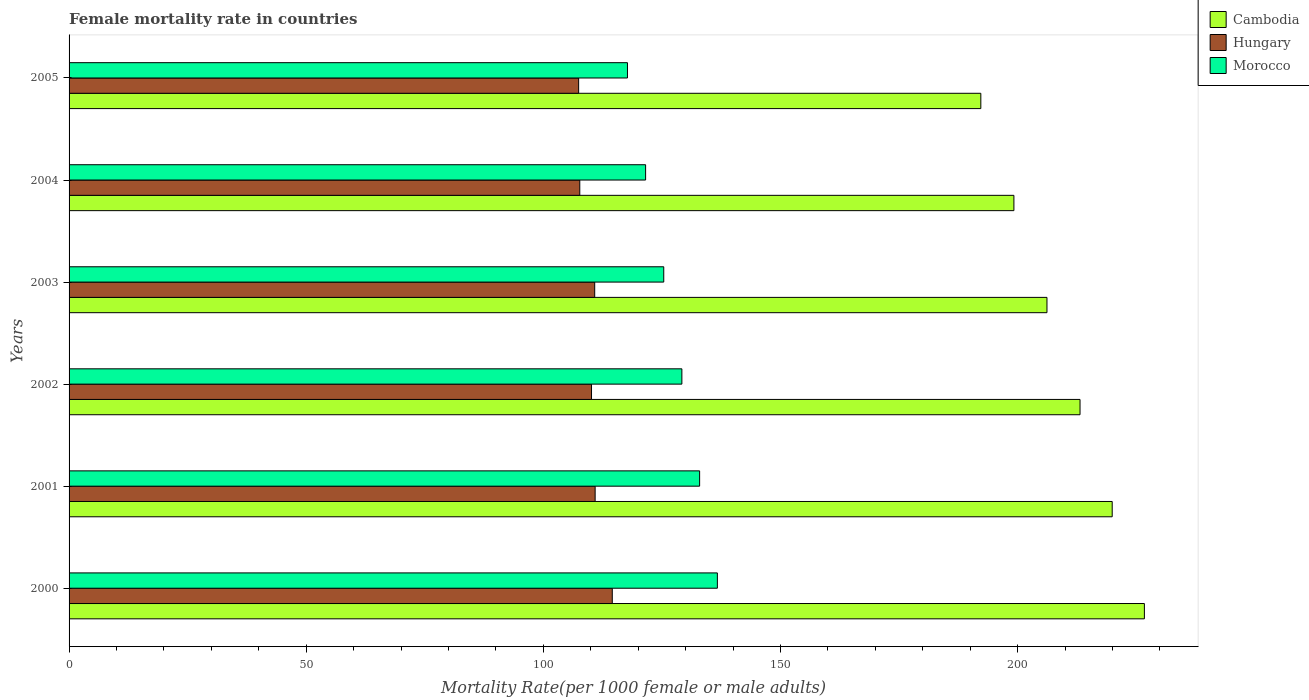How many different coloured bars are there?
Offer a terse response. 3. How many groups of bars are there?
Offer a terse response. 6. How many bars are there on the 3rd tick from the top?
Ensure brevity in your answer.  3. What is the label of the 3rd group of bars from the top?
Provide a succinct answer. 2003. In how many cases, is the number of bars for a given year not equal to the number of legend labels?
Offer a very short reply. 0. What is the female mortality rate in Hungary in 2005?
Your answer should be compact. 107.44. Across all years, what is the maximum female mortality rate in Morocco?
Your answer should be very brief. 136.69. Across all years, what is the minimum female mortality rate in Hungary?
Your answer should be compact. 107.44. In which year was the female mortality rate in Morocco minimum?
Keep it short and to the point. 2005. What is the total female mortality rate in Hungary in the graph?
Your response must be concise. 661.57. What is the difference between the female mortality rate in Hungary in 2002 and that in 2004?
Your response must be concise. 2.47. What is the difference between the female mortality rate in Hungary in 2003 and the female mortality rate in Cambodia in 2002?
Give a very brief answer. -102.33. What is the average female mortality rate in Morocco per year?
Offer a very short reply. 127.26. In the year 2003, what is the difference between the female mortality rate in Hungary and female mortality rate in Cambodia?
Keep it short and to the point. -95.36. In how many years, is the female mortality rate in Hungary greater than 210 ?
Offer a very short reply. 0. What is the ratio of the female mortality rate in Hungary in 2000 to that in 2001?
Your response must be concise. 1.03. Is the female mortality rate in Hungary in 2002 less than that in 2005?
Your response must be concise. No. Is the difference between the female mortality rate in Hungary in 2001 and 2004 greater than the difference between the female mortality rate in Cambodia in 2001 and 2004?
Ensure brevity in your answer.  No. What is the difference between the highest and the second highest female mortality rate in Hungary?
Keep it short and to the point. 3.61. What is the difference between the highest and the lowest female mortality rate in Morocco?
Ensure brevity in your answer.  18.95. In how many years, is the female mortality rate in Hungary greater than the average female mortality rate in Hungary taken over all years?
Your answer should be very brief. 3. Is the sum of the female mortality rate in Morocco in 2000 and 2001 greater than the maximum female mortality rate in Hungary across all years?
Ensure brevity in your answer.  Yes. What does the 3rd bar from the top in 2000 represents?
Offer a terse response. Cambodia. What does the 2nd bar from the bottom in 2000 represents?
Provide a succinct answer. Hungary. Is it the case that in every year, the sum of the female mortality rate in Cambodia and female mortality rate in Morocco is greater than the female mortality rate in Hungary?
Your response must be concise. Yes. Are all the bars in the graph horizontal?
Your answer should be very brief. Yes. What is the difference between two consecutive major ticks on the X-axis?
Keep it short and to the point. 50. Are the values on the major ticks of X-axis written in scientific E-notation?
Keep it short and to the point. No. Does the graph contain any zero values?
Provide a succinct answer. No. Where does the legend appear in the graph?
Offer a very short reply. Top right. How are the legend labels stacked?
Provide a short and direct response. Vertical. What is the title of the graph?
Keep it short and to the point. Female mortality rate in countries. Does "Algeria" appear as one of the legend labels in the graph?
Offer a very short reply. No. What is the label or title of the X-axis?
Offer a very short reply. Mortality Rate(per 1000 female or male adults). What is the label or title of the Y-axis?
Make the answer very short. Years. What is the Mortality Rate(per 1000 female or male adults) of Cambodia in 2000?
Your answer should be very brief. 226.73. What is the Mortality Rate(per 1000 female or male adults) in Hungary in 2000?
Offer a very short reply. 114.53. What is the Mortality Rate(per 1000 female or male adults) in Morocco in 2000?
Provide a succinct answer. 136.69. What is the Mortality Rate(per 1000 female or male adults) in Cambodia in 2001?
Your answer should be very brief. 219.95. What is the Mortality Rate(per 1000 female or male adults) in Hungary in 2001?
Give a very brief answer. 110.92. What is the Mortality Rate(per 1000 female or male adults) in Morocco in 2001?
Provide a short and direct response. 132.95. What is the Mortality Rate(per 1000 female or male adults) in Cambodia in 2002?
Give a very brief answer. 213.16. What is the Mortality Rate(per 1000 female or male adults) of Hungary in 2002?
Keep it short and to the point. 110.16. What is the Mortality Rate(per 1000 female or male adults) of Morocco in 2002?
Offer a very short reply. 129.21. What is the Mortality Rate(per 1000 female or male adults) of Cambodia in 2003?
Ensure brevity in your answer.  206.19. What is the Mortality Rate(per 1000 female or male adults) of Hungary in 2003?
Ensure brevity in your answer.  110.83. What is the Mortality Rate(per 1000 female or male adults) of Morocco in 2003?
Offer a terse response. 125.39. What is the Mortality Rate(per 1000 female or male adults) of Cambodia in 2004?
Keep it short and to the point. 199.22. What is the Mortality Rate(per 1000 female or male adults) in Hungary in 2004?
Your answer should be compact. 107.68. What is the Mortality Rate(per 1000 female or male adults) in Morocco in 2004?
Make the answer very short. 121.56. What is the Mortality Rate(per 1000 female or male adults) in Cambodia in 2005?
Your answer should be compact. 192.25. What is the Mortality Rate(per 1000 female or male adults) of Hungary in 2005?
Keep it short and to the point. 107.44. What is the Mortality Rate(per 1000 female or male adults) of Morocco in 2005?
Give a very brief answer. 117.74. Across all years, what is the maximum Mortality Rate(per 1000 female or male adults) in Cambodia?
Your response must be concise. 226.73. Across all years, what is the maximum Mortality Rate(per 1000 female or male adults) in Hungary?
Ensure brevity in your answer.  114.53. Across all years, what is the maximum Mortality Rate(per 1000 female or male adults) in Morocco?
Your answer should be very brief. 136.69. Across all years, what is the minimum Mortality Rate(per 1000 female or male adults) in Cambodia?
Your response must be concise. 192.25. Across all years, what is the minimum Mortality Rate(per 1000 female or male adults) in Hungary?
Provide a succinct answer. 107.44. Across all years, what is the minimum Mortality Rate(per 1000 female or male adults) in Morocco?
Offer a terse response. 117.74. What is the total Mortality Rate(per 1000 female or male adults) in Cambodia in the graph?
Ensure brevity in your answer.  1257.49. What is the total Mortality Rate(per 1000 female or male adults) of Hungary in the graph?
Give a very brief answer. 661.57. What is the total Mortality Rate(per 1000 female or male adults) of Morocco in the graph?
Keep it short and to the point. 763.55. What is the difference between the Mortality Rate(per 1000 female or male adults) in Cambodia in 2000 and that in 2001?
Your answer should be compact. 6.78. What is the difference between the Mortality Rate(per 1000 female or male adults) in Hungary in 2000 and that in 2001?
Your answer should be very brief. 3.61. What is the difference between the Mortality Rate(per 1000 female or male adults) of Morocco in 2000 and that in 2001?
Offer a terse response. 3.74. What is the difference between the Mortality Rate(per 1000 female or male adults) in Cambodia in 2000 and that in 2002?
Ensure brevity in your answer.  13.57. What is the difference between the Mortality Rate(per 1000 female or male adults) in Hungary in 2000 and that in 2002?
Keep it short and to the point. 4.38. What is the difference between the Mortality Rate(per 1000 female or male adults) in Morocco in 2000 and that in 2002?
Keep it short and to the point. 7.48. What is the difference between the Mortality Rate(per 1000 female or male adults) in Cambodia in 2000 and that in 2003?
Provide a short and direct response. 20.54. What is the difference between the Mortality Rate(per 1000 female or male adults) of Hungary in 2000 and that in 2003?
Provide a succinct answer. 3.71. What is the difference between the Mortality Rate(per 1000 female or male adults) in Morocco in 2000 and that in 2003?
Your answer should be compact. 11.31. What is the difference between the Mortality Rate(per 1000 female or male adults) in Cambodia in 2000 and that in 2004?
Keep it short and to the point. 27.51. What is the difference between the Mortality Rate(per 1000 female or male adults) of Hungary in 2000 and that in 2004?
Give a very brief answer. 6.85. What is the difference between the Mortality Rate(per 1000 female or male adults) in Morocco in 2000 and that in 2004?
Your answer should be compact. 15.13. What is the difference between the Mortality Rate(per 1000 female or male adults) of Cambodia in 2000 and that in 2005?
Provide a succinct answer. 34.48. What is the difference between the Mortality Rate(per 1000 female or male adults) in Hungary in 2000 and that in 2005?
Ensure brevity in your answer.  7.09. What is the difference between the Mortality Rate(per 1000 female or male adults) of Morocco in 2000 and that in 2005?
Provide a succinct answer. 18.95. What is the difference between the Mortality Rate(per 1000 female or male adults) of Cambodia in 2001 and that in 2002?
Offer a very short reply. 6.78. What is the difference between the Mortality Rate(per 1000 female or male adults) of Hungary in 2001 and that in 2002?
Your response must be concise. 0.77. What is the difference between the Mortality Rate(per 1000 female or male adults) of Morocco in 2001 and that in 2002?
Your response must be concise. 3.74. What is the difference between the Mortality Rate(per 1000 female or male adults) in Cambodia in 2001 and that in 2003?
Offer a very short reply. 13.76. What is the difference between the Mortality Rate(per 1000 female or male adults) in Hungary in 2001 and that in 2003?
Offer a very short reply. 0.09. What is the difference between the Mortality Rate(per 1000 female or male adults) of Morocco in 2001 and that in 2003?
Your answer should be very brief. 7.57. What is the difference between the Mortality Rate(per 1000 female or male adults) in Cambodia in 2001 and that in 2004?
Make the answer very short. 20.73. What is the difference between the Mortality Rate(per 1000 female or male adults) of Hungary in 2001 and that in 2004?
Keep it short and to the point. 3.24. What is the difference between the Mortality Rate(per 1000 female or male adults) in Morocco in 2001 and that in 2004?
Your answer should be compact. 11.39. What is the difference between the Mortality Rate(per 1000 female or male adults) of Cambodia in 2001 and that in 2005?
Give a very brief answer. 27.7. What is the difference between the Mortality Rate(per 1000 female or male adults) of Hungary in 2001 and that in 2005?
Keep it short and to the point. 3.48. What is the difference between the Mortality Rate(per 1000 female or male adults) in Morocco in 2001 and that in 2005?
Provide a succinct answer. 15.21. What is the difference between the Mortality Rate(per 1000 female or male adults) in Cambodia in 2002 and that in 2003?
Give a very brief answer. 6.97. What is the difference between the Mortality Rate(per 1000 female or male adults) in Hungary in 2002 and that in 2003?
Make the answer very short. -0.67. What is the difference between the Mortality Rate(per 1000 female or male adults) in Morocco in 2002 and that in 2003?
Your response must be concise. 3.82. What is the difference between the Mortality Rate(per 1000 female or male adults) of Cambodia in 2002 and that in 2004?
Your answer should be very brief. 13.94. What is the difference between the Mortality Rate(per 1000 female or male adults) in Hungary in 2002 and that in 2004?
Your answer should be very brief. 2.47. What is the difference between the Mortality Rate(per 1000 female or male adults) in Morocco in 2002 and that in 2004?
Provide a short and direct response. 7.65. What is the difference between the Mortality Rate(per 1000 female or male adults) in Cambodia in 2002 and that in 2005?
Offer a very short reply. 20.92. What is the difference between the Mortality Rate(per 1000 female or male adults) of Hungary in 2002 and that in 2005?
Give a very brief answer. 2.71. What is the difference between the Mortality Rate(per 1000 female or male adults) in Morocco in 2002 and that in 2005?
Offer a very short reply. 11.47. What is the difference between the Mortality Rate(per 1000 female or male adults) of Cambodia in 2003 and that in 2004?
Keep it short and to the point. 6.97. What is the difference between the Mortality Rate(per 1000 female or male adults) of Hungary in 2003 and that in 2004?
Provide a succinct answer. 3.15. What is the difference between the Mortality Rate(per 1000 female or male adults) of Morocco in 2003 and that in 2004?
Offer a very short reply. 3.82. What is the difference between the Mortality Rate(per 1000 female or male adults) of Cambodia in 2003 and that in 2005?
Make the answer very short. 13.95. What is the difference between the Mortality Rate(per 1000 female or male adults) of Hungary in 2003 and that in 2005?
Give a very brief answer. 3.39. What is the difference between the Mortality Rate(per 1000 female or male adults) in Morocco in 2003 and that in 2005?
Your response must be concise. 7.65. What is the difference between the Mortality Rate(per 1000 female or male adults) of Cambodia in 2004 and that in 2005?
Provide a short and direct response. 6.97. What is the difference between the Mortality Rate(per 1000 female or male adults) in Hungary in 2004 and that in 2005?
Make the answer very short. 0.24. What is the difference between the Mortality Rate(per 1000 female or male adults) of Morocco in 2004 and that in 2005?
Offer a very short reply. 3.82. What is the difference between the Mortality Rate(per 1000 female or male adults) in Cambodia in 2000 and the Mortality Rate(per 1000 female or male adults) in Hungary in 2001?
Offer a terse response. 115.81. What is the difference between the Mortality Rate(per 1000 female or male adults) in Cambodia in 2000 and the Mortality Rate(per 1000 female or male adults) in Morocco in 2001?
Offer a terse response. 93.78. What is the difference between the Mortality Rate(per 1000 female or male adults) of Hungary in 2000 and the Mortality Rate(per 1000 female or male adults) of Morocco in 2001?
Your response must be concise. -18.42. What is the difference between the Mortality Rate(per 1000 female or male adults) in Cambodia in 2000 and the Mortality Rate(per 1000 female or male adults) in Hungary in 2002?
Your answer should be very brief. 116.57. What is the difference between the Mortality Rate(per 1000 female or male adults) in Cambodia in 2000 and the Mortality Rate(per 1000 female or male adults) in Morocco in 2002?
Make the answer very short. 97.52. What is the difference between the Mortality Rate(per 1000 female or male adults) in Hungary in 2000 and the Mortality Rate(per 1000 female or male adults) in Morocco in 2002?
Ensure brevity in your answer.  -14.68. What is the difference between the Mortality Rate(per 1000 female or male adults) in Cambodia in 2000 and the Mortality Rate(per 1000 female or male adults) in Hungary in 2003?
Ensure brevity in your answer.  115.9. What is the difference between the Mortality Rate(per 1000 female or male adults) in Cambodia in 2000 and the Mortality Rate(per 1000 female or male adults) in Morocco in 2003?
Your answer should be very brief. 101.34. What is the difference between the Mortality Rate(per 1000 female or male adults) of Hungary in 2000 and the Mortality Rate(per 1000 female or male adults) of Morocco in 2003?
Keep it short and to the point. -10.85. What is the difference between the Mortality Rate(per 1000 female or male adults) of Cambodia in 2000 and the Mortality Rate(per 1000 female or male adults) of Hungary in 2004?
Provide a succinct answer. 119.05. What is the difference between the Mortality Rate(per 1000 female or male adults) of Cambodia in 2000 and the Mortality Rate(per 1000 female or male adults) of Morocco in 2004?
Your response must be concise. 105.17. What is the difference between the Mortality Rate(per 1000 female or male adults) of Hungary in 2000 and the Mortality Rate(per 1000 female or male adults) of Morocco in 2004?
Give a very brief answer. -7.03. What is the difference between the Mortality Rate(per 1000 female or male adults) in Cambodia in 2000 and the Mortality Rate(per 1000 female or male adults) in Hungary in 2005?
Your response must be concise. 119.29. What is the difference between the Mortality Rate(per 1000 female or male adults) of Cambodia in 2000 and the Mortality Rate(per 1000 female or male adults) of Morocco in 2005?
Provide a succinct answer. 108.99. What is the difference between the Mortality Rate(per 1000 female or male adults) in Hungary in 2000 and the Mortality Rate(per 1000 female or male adults) in Morocco in 2005?
Keep it short and to the point. -3.21. What is the difference between the Mortality Rate(per 1000 female or male adults) of Cambodia in 2001 and the Mortality Rate(per 1000 female or male adults) of Hungary in 2002?
Give a very brief answer. 109.79. What is the difference between the Mortality Rate(per 1000 female or male adults) of Cambodia in 2001 and the Mortality Rate(per 1000 female or male adults) of Morocco in 2002?
Ensure brevity in your answer.  90.73. What is the difference between the Mortality Rate(per 1000 female or male adults) in Hungary in 2001 and the Mortality Rate(per 1000 female or male adults) in Morocco in 2002?
Ensure brevity in your answer.  -18.29. What is the difference between the Mortality Rate(per 1000 female or male adults) of Cambodia in 2001 and the Mortality Rate(per 1000 female or male adults) of Hungary in 2003?
Ensure brevity in your answer.  109.12. What is the difference between the Mortality Rate(per 1000 female or male adults) of Cambodia in 2001 and the Mortality Rate(per 1000 female or male adults) of Morocco in 2003?
Offer a terse response. 94.56. What is the difference between the Mortality Rate(per 1000 female or male adults) in Hungary in 2001 and the Mortality Rate(per 1000 female or male adults) in Morocco in 2003?
Make the answer very short. -14.46. What is the difference between the Mortality Rate(per 1000 female or male adults) in Cambodia in 2001 and the Mortality Rate(per 1000 female or male adults) in Hungary in 2004?
Offer a very short reply. 112.26. What is the difference between the Mortality Rate(per 1000 female or male adults) in Cambodia in 2001 and the Mortality Rate(per 1000 female or male adults) in Morocco in 2004?
Ensure brevity in your answer.  98.38. What is the difference between the Mortality Rate(per 1000 female or male adults) of Hungary in 2001 and the Mortality Rate(per 1000 female or male adults) of Morocco in 2004?
Provide a succinct answer. -10.64. What is the difference between the Mortality Rate(per 1000 female or male adults) of Cambodia in 2001 and the Mortality Rate(per 1000 female or male adults) of Hungary in 2005?
Make the answer very short. 112.5. What is the difference between the Mortality Rate(per 1000 female or male adults) of Cambodia in 2001 and the Mortality Rate(per 1000 female or male adults) of Morocco in 2005?
Keep it short and to the point. 102.21. What is the difference between the Mortality Rate(per 1000 female or male adults) in Hungary in 2001 and the Mortality Rate(per 1000 female or male adults) in Morocco in 2005?
Your answer should be compact. -6.82. What is the difference between the Mortality Rate(per 1000 female or male adults) in Cambodia in 2002 and the Mortality Rate(per 1000 female or male adults) in Hungary in 2003?
Make the answer very short. 102.33. What is the difference between the Mortality Rate(per 1000 female or male adults) of Cambodia in 2002 and the Mortality Rate(per 1000 female or male adults) of Morocco in 2003?
Offer a very short reply. 87.78. What is the difference between the Mortality Rate(per 1000 female or male adults) in Hungary in 2002 and the Mortality Rate(per 1000 female or male adults) in Morocco in 2003?
Give a very brief answer. -15.23. What is the difference between the Mortality Rate(per 1000 female or male adults) of Cambodia in 2002 and the Mortality Rate(per 1000 female or male adults) of Hungary in 2004?
Give a very brief answer. 105.48. What is the difference between the Mortality Rate(per 1000 female or male adults) in Cambodia in 2002 and the Mortality Rate(per 1000 female or male adults) in Morocco in 2004?
Your answer should be compact. 91.6. What is the difference between the Mortality Rate(per 1000 female or male adults) in Hungary in 2002 and the Mortality Rate(per 1000 female or male adults) in Morocco in 2004?
Provide a succinct answer. -11.41. What is the difference between the Mortality Rate(per 1000 female or male adults) of Cambodia in 2002 and the Mortality Rate(per 1000 female or male adults) of Hungary in 2005?
Provide a succinct answer. 105.72. What is the difference between the Mortality Rate(per 1000 female or male adults) of Cambodia in 2002 and the Mortality Rate(per 1000 female or male adults) of Morocco in 2005?
Keep it short and to the point. 95.42. What is the difference between the Mortality Rate(per 1000 female or male adults) of Hungary in 2002 and the Mortality Rate(per 1000 female or male adults) of Morocco in 2005?
Make the answer very short. -7.58. What is the difference between the Mortality Rate(per 1000 female or male adults) in Cambodia in 2003 and the Mortality Rate(per 1000 female or male adults) in Hungary in 2004?
Provide a short and direct response. 98.51. What is the difference between the Mortality Rate(per 1000 female or male adults) of Cambodia in 2003 and the Mortality Rate(per 1000 female or male adults) of Morocco in 2004?
Make the answer very short. 84.63. What is the difference between the Mortality Rate(per 1000 female or male adults) of Hungary in 2003 and the Mortality Rate(per 1000 female or male adults) of Morocco in 2004?
Offer a very short reply. -10.73. What is the difference between the Mortality Rate(per 1000 female or male adults) of Cambodia in 2003 and the Mortality Rate(per 1000 female or male adults) of Hungary in 2005?
Make the answer very short. 98.75. What is the difference between the Mortality Rate(per 1000 female or male adults) in Cambodia in 2003 and the Mortality Rate(per 1000 female or male adults) in Morocco in 2005?
Your answer should be very brief. 88.45. What is the difference between the Mortality Rate(per 1000 female or male adults) of Hungary in 2003 and the Mortality Rate(per 1000 female or male adults) of Morocco in 2005?
Your answer should be compact. -6.91. What is the difference between the Mortality Rate(per 1000 female or male adults) in Cambodia in 2004 and the Mortality Rate(per 1000 female or male adults) in Hungary in 2005?
Your answer should be very brief. 91.77. What is the difference between the Mortality Rate(per 1000 female or male adults) of Cambodia in 2004 and the Mortality Rate(per 1000 female or male adults) of Morocco in 2005?
Offer a very short reply. 81.48. What is the difference between the Mortality Rate(per 1000 female or male adults) in Hungary in 2004 and the Mortality Rate(per 1000 female or male adults) in Morocco in 2005?
Provide a short and direct response. -10.06. What is the average Mortality Rate(per 1000 female or male adults) in Cambodia per year?
Provide a succinct answer. 209.58. What is the average Mortality Rate(per 1000 female or male adults) of Hungary per year?
Make the answer very short. 110.26. What is the average Mortality Rate(per 1000 female or male adults) in Morocco per year?
Ensure brevity in your answer.  127.26. In the year 2000, what is the difference between the Mortality Rate(per 1000 female or male adults) of Cambodia and Mortality Rate(per 1000 female or male adults) of Hungary?
Your answer should be compact. 112.19. In the year 2000, what is the difference between the Mortality Rate(per 1000 female or male adults) of Cambodia and Mortality Rate(per 1000 female or male adults) of Morocco?
Provide a short and direct response. 90.04. In the year 2000, what is the difference between the Mortality Rate(per 1000 female or male adults) in Hungary and Mortality Rate(per 1000 female or male adults) in Morocco?
Provide a short and direct response. -22.16. In the year 2001, what is the difference between the Mortality Rate(per 1000 female or male adults) of Cambodia and Mortality Rate(per 1000 female or male adults) of Hungary?
Ensure brevity in your answer.  109.02. In the year 2001, what is the difference between the Mortality Rate(per 1000 female or male adults) in Cambodia and Mortality Rate(per 1000 female or male adults) in Morocco?
Your answer should be very brief. 86.99. In the year 2001, what is the difference between the Mortality Rate(per 1000 female or male adults) in Hungary and Mortality Rate(per 1000 female or male adults) in Morocco?
Your answer should be compact. -22.03. In the year 2002, what is the difference between the Mortality Rate(per 1000 female or male adults) in Cambodia and Mortality Rate(per 1000 female or male adults) in Hungary?
Offer a terse response. 103. In the year 2002, what is the difference between the Mortality Rate(per 1000 female or male adults) of Cambodia and Mortality Rate(per 1000 female or male adults) of Morocco?
Offer a terse response. 83.95. In the year 2002, what is the difference between the Mortality Rate(per 1000 female or male adults) of Hungary and Mortality Rate(per 1000 female or male adults) of Morocco?
Offer a terse response. -19.05. In the year 2003, what is the difference between the Mortality Rate(per 1000 female or male adults) of Cambodia and Mortality Rate(per 1000 female or male adults) of Hungary?
Provide a succinct answer. 95.36. In the year 2003, what is the difference between the Mortality Rate(per 1000 female or male adults) of Cambodia and Mortality Rate(per 1000 female or male adults) of Morocco?
Offer a very short reply. 80.8. In the year 2003, what is the difference between the Mortality Rate(per 1000 female or male adults) of Hungary and Mortality Rate(per 1000 female or male adults) of Morocco?
Give a very brief answer. -14.56. In the year 2004, what is the difference between the Mortality Rate(per 1000 female or male adults) of Cambodia and Mortality Rate(per 1000 female or male adults) of Hungary?
Your answer should be very brief. 91.53. In the year 2004, what is the difference between the Mortality Rate(per 1000 female or male adults) in Cambodia and Mortality Rate(per 1000 female or male adults) in Morocco?
Provide a succinct answer. 77.65. In the year 2004, what is the difference between the Mortality Rate(per 1000 female or male adults) of Hungary and Mortality Rate(per 1000 female or male adults) of Morocco?
Give a very brief answer. -13.88. In the year 2005, what is the difference between the Mortality Rate(per 1000 female or male adults) in Cambodia and Mortality Rate(per 1000 female or male adults) in Hungary?
Provide a short and direct response. 84.8. In the year 2005, what is the difference between the Mortality Rate(per 1000 female or male adults) in Cambodia and Mortality Rate(per 1000 female or male adults) in Morocco?
Provide a succinct answer. 74.5. In the year 2005, what is the difference between the Mortality Rate(per 1000 female or male adults) in Hungary and Mortality Rate(per 1000 female or male adults) in Morocco?
Ensure brevity in your answer.  -10.3. What is the ratio of the Mortality Rate(per 1000 female or male adults) of Cambodia in 2000 to that in 2001?
Make the answer very short. 1.03. What is the ratio of the Mortality Rate(per 1000 female or male adults) of Hungary in 2000 to that in 2001?
Give a very brief answer. 1.03. What is the ratio of the Mortality Rate(per 1000 female or male adults) in Morocco in 2000 to that in 2001?
Provide a succinct answer. 1.03. What is the ratio of the Mortality Rate(per 1000 female or male adults) in Cambodia in 2000 to that in 2002?
Provide a succinct answer. 1.06. What is the ratio of the Mortality Rate(per 1000 female or male adults) in Hungary in 2000 to that in 2002?
Provide a short and direct response. 1.04. What is the ratio of the Mortality Rate(per 1000 female or male adults) of Morocco in 2000 to that in 2002?
Your response must be concise. 1.06. What is the ratio of the Mortality Rate(per 1000 female or male adults) of Cambodia in 2000 to that in 2003?
Your response must be concise. 1.1. What is the ratio of the Mortality Rate(per 1000 female or male adults) in Hungary in 2000 to that in 2003?
Make the answer very short. 1.03. What is the ratio of the Mortality Rate(per 1000 female or male adults) of Morocco in 2000 to that in 2003?
Keep it short and to the point. 1.09. What is the ratio of the Mortality Rate(per 1000 female or male adults) of Cambodia in 2000 to that in 2004?
Provide a short and direct response. 1.14. What is the ratio of the Mortality Rate(per 1000 female or male adults) of Hungary in 2000 to that in 2004?
Provide a succinct answer. 1.06. What is the ratio of the Mortality Rate(per 1000 female or male adults) of Morocco in 2000 to that in 2004?
Provide a short and direct response. 1.12. What is the ratio of the Mortality Rate(per 1000 female or male adults) of Cambodia in 2000 to that in 2005?
Offer a very short reply. 1.18. What is the ratio of the Mortality Rate(per 1000 female or male adults) in Hungary in 2000 to that in 2005?
Keep it short and to the point. 1.07. What is the ratio of the Mortality Rate(per 1000 female or male adults) in Morocco in 2000 to that in 2005?
Make the answer very short. 1.16. What is the ratio of the Mortality Rate(per 1000 female or male adults) of Cambodia in 2001 to that in 2002?
Make the answer very short. 1.03. What is the ratio of the Mortality Rate(per 1000 female or male adults) in Cambodia in 2001 to that in 2003?
Your answer should be compact. 1.07. What is the ratio of the Mortality Rate(per 1000 female or male adults) of Hungary in 2001 to that in 2003?
Provide a succinct answer. 1. What is the ratio of the Mortality Rate(per 1000 female or male adults) of Morocco in 2001 to that in 2003?
Your answer should be compact. 1.06. What is the ratio of the Mortality Rate(per 1000 female or male adults) of Cambodia in 2001 to that in 2004?
Make the answer very short. 1.1. What is the ratio of the Mortality Rate(per 1000 female or male adults) in Hungary in 2001 to that in 2004?
Provide a succinct answer. 1.03. What is the ratio of the Mortality Rate(per 1000 female or male adults) of Morocco in 2001 to that in 2004?
Keep it short and to the point. 1.09. What is the ratio of the Mortality Rate(per 1000 female or male adults) in Cambodia in 2001 to that in 2005?
Provide a short and direct response. 1.14. What is the ratio of the Mortality Rate(per 1000 female or male adults) in Hungary in 2001 to that in 2005?
Give a very brief answer. 1.03. What is the ratio of the Mortality Rate(per 1000 female or male adults) in Morocco in 2001 to that in 2005?
Offer a terse response. 1.13. What is the ratio of the Mortality Rate(per 1000 female or male adults) of Cambodia in 2002 to that in 2003?
Give a very brief answer. 1.03. What is the ratio of the Mortality Rate(per 1000 female or male adults) in Morocco in 2002 to that in 2003?
Keep it short and to the point. 1.03. What is the ratio of the Mortality Rate(per 1000 female or male adults) in Cambodia in 2002 to that in 2004?
Give a very brief answer. 1.07. What is the ratio of the Mortality Rate(per 1000 female or male adults) in Morocco in 2002 to that in 2004?
Offer a very short reply. 1.06. What is the ratio of the Mortality Rate(per 1000 female or male adults) in Cambodia in 2002 to that in 2005?
Give a very brief answer. 1.11. What is the ratio of the Mortality Rate(per 1000 female or male adults) in Hungary in 2002 to that in 2005?
Your answer should be compact. 1.03. What is the ratio of the Mortality Rate(per 1000 female or male adults) in Morocco in 2002 to that in 2005?
Provide a succinct answer. 1.1. What is the ratio of the Mortality Rate(per 1000 female or male adults) in Cambodia in 2003 to that in 2004?
Provide a short and direct response. 1.03. What is the ratio of the Mortality Rate(per 1000 female or male adults) in Hungary in 2003 to that in 2004?
Provide a succinct answer. 1.03. What is the ratio of the Mortality Rate(per 1000 female or male adults) of Morocco in 2003 to that in 2004?
Keep it short and to the point. 1.03. What is the ratio of the Mortality Rate(per 1000 female or male adults) in Cambodia in 2003 to that in 2005?
Your answer should be very brief. 1.07. What is the ratio of the Mortality Rate(per 1000 female or male adults) of Hungary in 2003 to that in 2005?
Keep it short and to the point. 1.03. What is the ratio of the Mortality Rate(per 1000 female or male adults) of Morocco in 2003 to that in 2005?
Your answer should be very brief. 1.06. What is the ratio of the Mortality Rate(per 1000 female or male adults) in Cambodia in 2004 to that in 2005?
Give a very brief answer. 1.04. What is the ratio of the Mortality Rate(per 1000 female or male adults) of Morocco in 2004 to that in 2005?
Make the answer very short. 1.03. What is the difference between the highest and the second highest Mortality Rate(per 1000 female or male adults) of Cambodia?
Offer a very short reply. 6.78. What is the difference between the highest and the second highest Mortality Rate(per 1000 female or male adults) in Hungary?
Provide a short and direct response. 3.61. What is the difference between the highest and the second highest Mortality Rate(per 1000 female or male adults) of Morocco?
Offer a very short reply. 3.74. What is the difference between the highest and the lowest Mortality Rate(per 1000 female or male adults) in Cambodia?
Make the answer very short. 34.48. What is the difference between the highest and the lowest Mortality Rate(per 1000 female or male adults) in Hungary?
Your answer should be compact. 7.09. What is the difference between the highest and the lowest Mortality Rate(per 1000 female or male adults) in Morocco?
Provide a succinct answer. 18.95. 